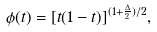Convert formula to latex. <formula><loc_0><loc_0><loc_500><loc_500>\phi ( t ) = [ t ( 1 - t ) ] ^ { ( 1 + \frac { \Delta } { 2 } ) / 2 } ,</formula> 